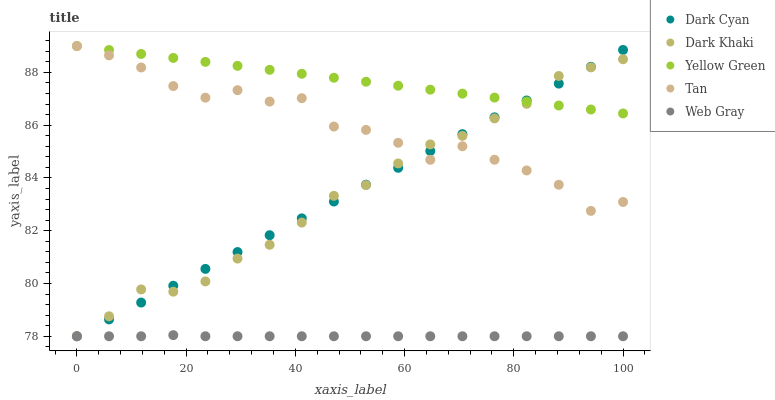Does Web Gray have the minimum area under the curve?
Answer yes or no. Yes. Does Yellow Green have the maximum area under the curve?
Answer yes or no. Yes. Does Dark Khaki have the minimum area under the curve?
Answer yes or no. No. Does Dark Khaki have the maximum area under the curve?
Answer yes or no. No. Is Yellow Green the smoothest?
Answer yes or no. Yes. Is Tan the roughest?
Answer yes or no. Yes. Is Dark Khaki the smoothest?
Answer yes or no. No. Is Dark Khaki the roughest?
Answer yes or no. No. Does Dark Cyan have the lowest value?
Answer yes or no. Yes. Does Tan have the lowest value?
Answer yes or no. No. Does Yellow Green have the highest value?
Answer yes or no. Yes. Does Dark Khaki have the highest value?
Answer yes or no. No. Is Web Gray less than Yellow Green?
Answer yes or no. Yes. Is Yellow Green greater than Web Gray?
Answer yes or no. Yes. Does Web Gray intersect Dark Cyan?
Answer yes or no. Yes. Is Web Gray less than Dark Cyan?
Answer yes or no. No. Is Web Gray greater than Dark Cyan?
Answer yes or no. No. Does Web Gray intersect Yellow Green?
Answer yes or no. No. 